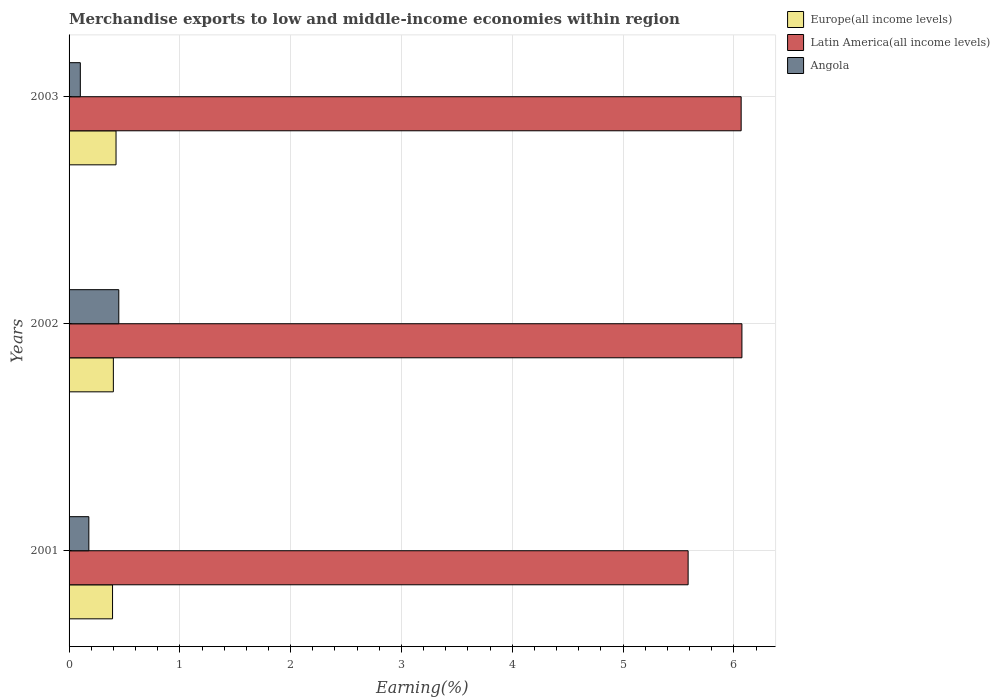How many different coloured bars are there?
Your answer should be very brief. 3. Are the number of bars per tick equal to the number of legend labels?
Offer a terse response. Yes. How many bars are there on the 3rd tick from the bottom?
Provide a short and direct response. 3. What is the percentage of amount earned from merchandise exports in Angola in 2002?
Provide a succinct answer. 0.45. Across all years, what is the maximum percentage of amount earned from merchandise exports in Angola?
Give a very brief answer. 0.45. Across all years, what is the minimum percentage of amount earned from merchandise exports in Angola?
Give a very brief answer. 0.1. What is the total percentage of amount earned from merchandise exports in Europe(all income levels) in the graph?
Make the answer very short. 1.22. What is the difference between the percentage of amount earned from merchandise exports in Latin America(all income levels) in 2001 and that in 2003?
Provide a succinct answer. -0.48. What is the difference between the percentage of amount earned from merchandise exports in Latin America(all income levels) in 2001 and the percentage of amount earned from merchandise exports in Europe(all income levels) in 2002?
Give a very brief answer. 5.19. What is the average percentage of amount earned from merchandise exports in Europe(all income levels) per year?
Keep it short and to the point. 0.41. In the year 2003, what is the difference between the percentage of amount earned from merchandise exports in Angola and percentage of amount earned from merchandise exports in Latin America(all income levels)?
Keep it short and to the point. -5.96. In how many years, is the percentage of amount earned from merchandise exports in Latin America(all income levels) greater than 2.2 %?
Offer a very short reply. 3. What is the ratio of the percentage of amount earned from merchandise exports in Angola in 2002 to that in 2003?
Keep it short and to the point. 4.42. Is the difference between the percentage of amount earned from merchandise exports in Angola in 2001 and 2002 greater than the difference between the percentage of amount earned from merchandise exports in Latin America(all income levels) in 2001 and 2002?
Ensure brevity in your answer.  Yes. What is the difference between the highest and the second highest percentage of amount earned from merchandise exports in Latin America(all income levels)?
Keep it short and to the point. 0.01. What is the difference between the highest and the lowest percentage of amount earned from merchandise exports in Europe(all income levels)?
Offer a very short reply. 0.03. Is the sum of the percentage of amount earned from merchandise exports in Angola in 2001 and 2003 greater than the maximum percentage of amount earned from merchandise exports in Latin America(all income levels) across all years?
Keep it short and to the point. No. What does the 2nd bar from the top in 2003 represents?
Keep it short and to the point. Latin America(all income levels). What does the 3rd bar from the bottom in 2002 represents?
Keep it short and to the point. Angola. How many bars are there?
Your answer should be compact. 9. Are all the bars in the graph horizontal?
Your answer should be compact. Yes. How many years are there in the graph?
Offer a terse response. 3. What is the difference between two consecutive major ticks on the X-axis?
Provide a succinct answer. 1. Are the values on the major ticks of X-axis written in scientific E-notation?
Provide a short and direct response. No. Does the graph contain any zero values?
Provide a succinct answer. No. How many legend labels are there?
Your response must be concise. 3. What is the title of the graph?
Give a very brief answer. Merchandise exports to low and middle-income economies within region. Does "West Bank and Gaza" appear as one of the legend labels in the graph?
Your response must be concise. No. What is the label or title of the X-axis?
Provide a short and direct response. Earning(%). What is the Earning(%) in Europe(all income levels) in 2001?
Make the answer very short. 0.39. What is the Earning(%) in Latin America(all income levels) in 2001?
Give a very brief answer. 5.59. What is the Earning(%) of Angola in 2001?
Keep it short and to the point. 0.18. What is the Earning(%) in Europe(all income levels) in 2002?
Give a very brief answer. 0.4. What is the Earning(%) of Latin America(all income levels) in 2002?
Make the answer very short. 6.07. What is the Earning(%) of Angola in 2002?
Give a very brief answer. 0.45. What is the Earning(%) of Europe(all income levels) in 2003?
Provide a succinct answer. 0.42. What is the Earning(%) of Latin America(all income levels) in 2003?
Offer a terse response. 6.07. What is the Earning(%) of Angola in 2003?
Your answer should be compact. 0.1. Across all years, what is the maximum Earning(%) in Europe(all income levels)?
Give a very brief answer. 0.42. Across all years, what is the maximum Earning(%) in Latin America(all income levels)?
Offer a terse response. 6.07. Across all years, what is the maximum Earning(%) of Angola?
Your answer should be compact. 0.45. Across all years, what is the minimum Earning(%) of Europe(all income levels)?
Offer a very short reply. 0.39. Across all years, what is the minimum Earning(%) in Latin America(all income levels)?
Make the answer very short. 5.59. Across all years, what is the minimum Earning(%) in Angola?
Ensure brevity in your answer.  0.1. What is the total Earning(%) in Europe(all income levels) in the graph?
Offer a very short reply. 1.22. What is the total Earning(%) of Latin America(all income levels) in the graph?
Your answer should be very brief. 17.73. What is the total Earning(%) of Angola in the graph?
Offer a terse response. 0.73. What is the difference between the Earning(%) of Europe(all income levels) in 2001 and that in 2002?
Give a very brief answer. -0.01. What is the difference between the Earning(%) in Latin America(all income levels) in 2001 and that in 2002?
Offer a very short reply. -0.49. What is the difference between the Earning(%) in Angola in 2001 and that in 2002?
Keep it short and to the point. -0.27. What is the difference between the Earning(%) of Europe(all income levels) in 2001 and that in 2003?
Your answer should be compact. -0.03. What is the difference between the Earning(%) of Latin America(all income levels) in 2001 and that in 2003?
Your response must be concise. -0.48. What is the difference between the Earning(%) of Angola in 2001 and that in 2003?
Your response must be concise. 0.08. What is the difference between the Earning(%) of Europe(all income levels) in 2002 and that in 2003?
Your response must be concise. -0.02. What is the difference between the Earning(%) of Latin America(all income levels) in 2002 and that in 2003?
Your answer should be very brief. 0.01. What is the difference between the Earning(%) of Angola in 2002 and that in 2003?
Give a very brief answer. 0.35. What is the difference between the Earning(%) of Europe(all income levels) in 2001 and the Earning(%) of Latin America(all income levels) in 2002?
Your answer should be very brief. -5.68. What is the difference between the Earning(%) of Europe(all income levels) in 2001 and the Earning(%) of Angola in 2002?
Ensure brevity in your answer.  -0.06. What is the difference between the Earning(%) of Latin America(all income levels) in 2001 and the Earning(%) of Angola in 2002?
Your answer should be compact. 5.14. What is the difference between the Earning(%) in Europe(all income levels) in 2001 and the Earning(%) in Latin America(all income levels) in 2003?
Keep it short and to the point. -5.67. What is the difference between the Earning(%) in Europe(all income levels) in 2001 and the Earning(%) in Angola in 2003?
Make the answer very short. 0.29. What is the difference between the Earning(%) of Latin America(all income levels) in 2001 and the Earning(%) of Angola in 2003?
Your answer should be very brief. 5.49. What is the difference between the Earning(%) of Europe(all income levels) in 2002 and the Earning(%) of Latin America(all income levels) in 2003?
Provide a short and direct response. -5.67. What is the difference between the Earning(%) in Europe(all income levels) in 2002 and the Earning(%) in Angola in 2003?
Ensure brevity in your answer.  0.3. What is the difference between the Earning(%) in Latin America(all income levels) in 2002 and the Earning(%) in Angola in 2003?
Ensure brevity in your answer.  5.97. What is the average Earning(%) in Europe(all income levels) per year?
Make the answer very short. 0.41. What is the average Earning(%) of Latin America(all income levels) per year?
Keep it short and to the point. 5.91. What is the average Earning(%) in Angola per year?
Offer a very short reply. 0.24. In the year 2001, what is the difference between the Earning(%) in Europe(all income levels) and Earning(%) in Latin America(all income levels)?
Your response must be concise. -5.2. In the year 2001, what is the difference between the Earning(%) in Europe(all income levels) and Earning(%) in Angola?
Your response must be concise. 0.21. In the year 2001, what is the difference between the Earning(%) in Latin America(all income levels) and Earning(%) in Angola?
Your answer should be compact. 5.41. In the year 2002, what is the difference between the Earning(%) in Europe(all income levels) and Earning(%) in Latin America(all income levels)?
Your answer should be very brief. -5.67. In the year 2002, what is the difference between the Earning(%) of Europe(all income levels) and Earning(%) of Angola?
Your response must be concise. -0.05. In the year 2002, what is the difference between the Earning(%) of Latin America(all income levels) and Earning(%) of Angola?
Make the answer very short. 5.62. In the year 2003, what is the difference between the Earning(%) of Europe(all income levels) and Earning(%) of Latin America(all income levels)?
Your response must be concise. -5.64. In the year 2003, what is the difference between the Earning(%) in Europe(all income levels) and Earning(%) in Angola?
Give a very brief answer. 0.32. In the year 2003, what is the difference between the Earning(%) of Latin America(all income levels) and Earning(%) of Angola?
Provide a succinct answer. 5.96. What is the ratio of the Earning(%) of Europe(all income levels) in 2001 to that in 2002?
Provide a succinct answer. 0.98. What is the ratio of the Earning(%) in Latin America(all income levels) in 2001 to that in 2002?
Your answer should be compact. 0.92. What is the ratio of the Earning(%) of Angola in 2001 to that in 2002?
Make the answer very short. 0.4. What is the ratio of the Earning(%) in Europe(all income levels) in 2001 to that in 2003?
Offer a very short reply. 0.93. What is the ratio of the Earning(%) in Latin America(all income levels) in 2001 to that in 2003?
Offer a very short reply. 0.92. What is the ratio of the Earning(%) of Angola in 2001 to that in 2003?
Your answer should be very brief. 1.76. What is the ratio of the Earning(%) in Europe(all income levels) in 2002 to that in 2003?
Ensure brevity in your answer.  0.94. What is the ratio of the Earning(%) in Latin America(all income levels) in 2002 to that in 2003?
Offer a very short reply. 1. What is the ratio of the Earning(%) in Angola in 2002 to that in 2003?
Make the answer very short. 4.42. What is the difference between the highest and the second highest Earning(%) in Europe(all income levels)?
Your answer should be compact. 0.02. What is the difference between the highest and the second highest Earning(%) of Latin America(all income levels)?
Your answer should be very brief. 0.01. What is the difference between the highest and the second highest Earning(%) in Angola?
Ensure brevity in your answer.  0.27. What is the difference between the highest and the lowest Earning(%) in Europe(all income levels)?
Provide a succinct answer. 0.03. What is the difference between the highest and the lowest Earning(%) of Latin America(all income levels)?
Your response must be concise. 0.49. What is the difference between the highest and the lowest Earning(%) in Angola?
Make the answer very short. 0.35. 